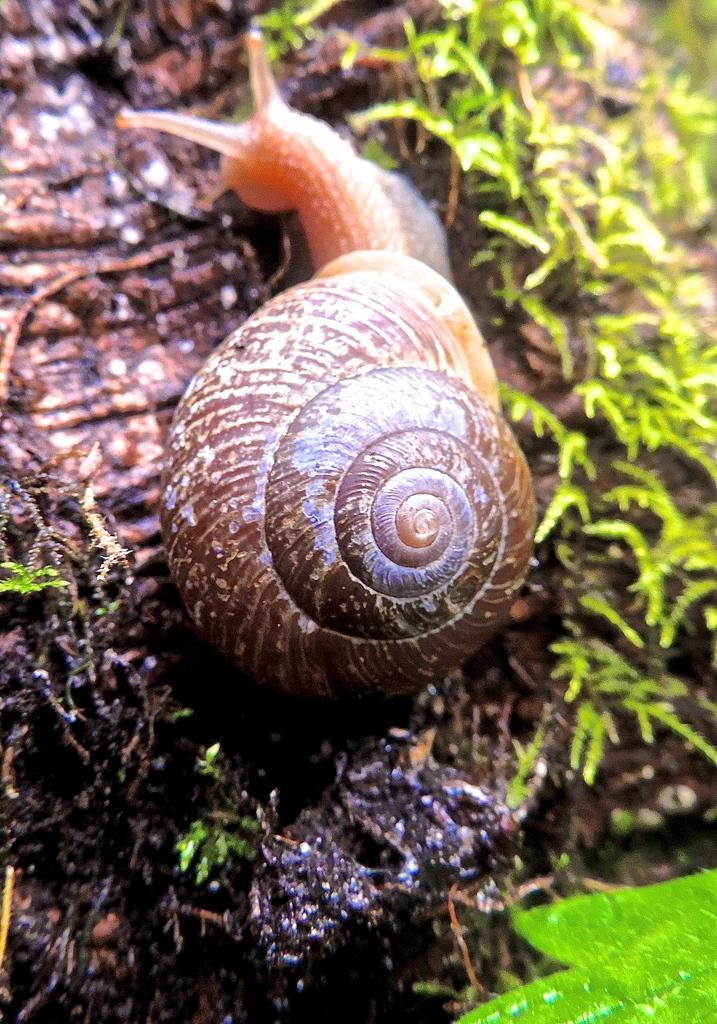What type of animal is in the image? There is a snail in the image. Where is the snail located? The snail is on land. What other living organisms can be seen in the image? There are small plants in the image. What reason does the snail give for being in the image? Snails do not have the ability to give reasons or communicate in that manner, so there is no reason provided by the snail in the image. 